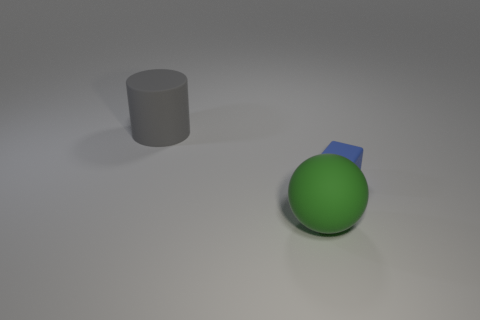How many cylinders are either big green rubber objects or small objects?
Offer a terse response. 0. What is the color of the large sphere that is the same material as the large gray cylinder?
Give a very brief answer. Green. Are there fewer purple cylinders than big rubber balls?
Your answer should be very brief. Yes. There is a object that is behind the blue matte object; is its shape the same as the rubber thing that is in front of the small rubber cube?
Offer a terse response. No. What number of things are either large green things or small blue metallic things?
Make the answer very short. 1. There is a rubber object that is the same size as the cylinder; what color is it?
Make the answer very short. Green. What number of large gray cylinders are behind the large object that is behind the green object?
Make the answer very short. 0. How many objects are both behind the big green sphere and on the right side of the gray matte thing?
Offer a very short reply. 1. What number of objects are either rubber objects to the left of the large green rubber ball or gray matte things behind the tiny blue cube?
Ensure brevity in your answer.  1. How many other objects are there of the same size as the green matte sphere?
Offer a very short reply. 1. 